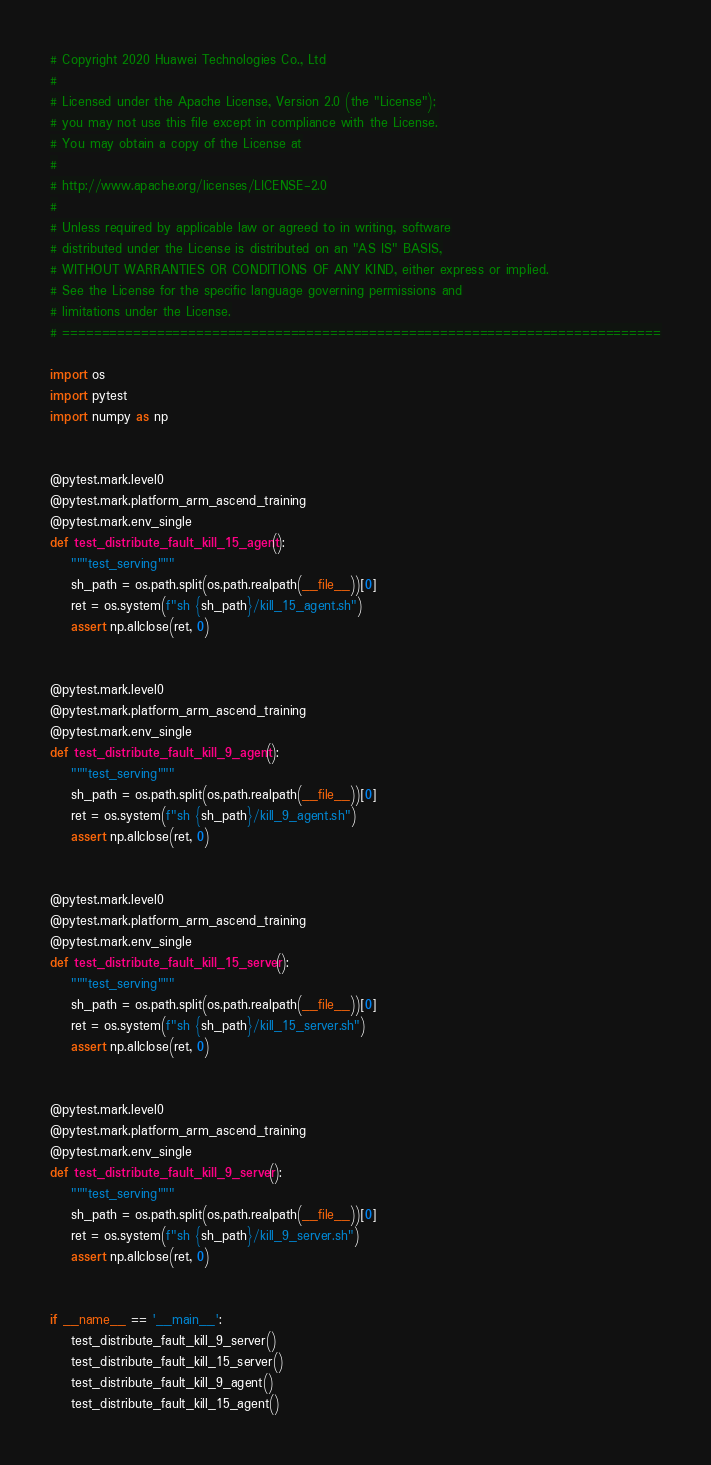<code> <loc_0><loc_0><loc_500><loc_500><_Python_># Copyright 2020 Huawei Technologies Co., Ltd
#
# Licensed under the Apache License, Version 2.0 (the "License");
# you may not use this file except in compliance with the License.
# You may obtain a copy of the License at
#
# http://www.apache.org/licenses/LICENSE-2.0
#
# Unless required by applicable law or agreed to in writing, software
# distributed under the License is distributed on an "AS IS" BASIS,
# WITHOUT WARRANTIES OR CONDITIONS OF ANY KIND, either express or implied.
# See the License for the specific language governing permissions and
# limitations under the License.
# ============================================================================

import os
import pytest
import numpy as np


@pytest.mark.level0
@pytest.mark.platform_arm_ascend_training
@pytest.mark.env_single
def test_distribute_fault_kill_15_agent():
    """test_serving"""
    sh_path = os.path.split(os.path.realpath(__file__))[0]
    ret = os.system(f"sh {sh_path}/kill_15_agent.sh")
    assert np.allclose(ret, 0)


@pytest.mark.level0
@pytest.mark.platform_arm_ascend_training
@pytest.mark.env_single
def test_distribute_fault_kill_9_agent():
    """test_serving"""
    sh_path = os.path.split(os.path.realpath(__file__))[0]
    ret = os.system(f"sh {sh_path}/kill_9_agent.sh")
    assert np.allclose(ret, 0)


@pytest.mark.level0
@pytest.mark.platform_arm_ascend_training
@pytest.mark.env_single
def test_distribute_fault_kill_15_server():
    """test_serving"""
    sh_path = os.path.split(os.path.realpath(__file__))[0]
    ret = os.system(f"sh {sh_path}/kill_15_server.sh")
    assert np.allclose(ret, 0)


@pytest.mark.level0
@pytest.mark.platform_arm_ascend_training
@pytest.mark.env_single
def test_distribute_fault_kill_9_server():
    """test_serving"""
    sh_path = os.path.split(os.path.realpath(__file__))[0]
    ret = os.system(f"sh {sh_path}/kill_9_server.sh")
    assert np.allclose(ret, 0)


if __name__ == '__main__':
    test_distribute_fault_kill_9_server()
    test_distribute_fault_kill_15_server()
    test_distribute_fault_kill_9_agent()
    test_distribute_fault_kill_15_agent()
</code> 